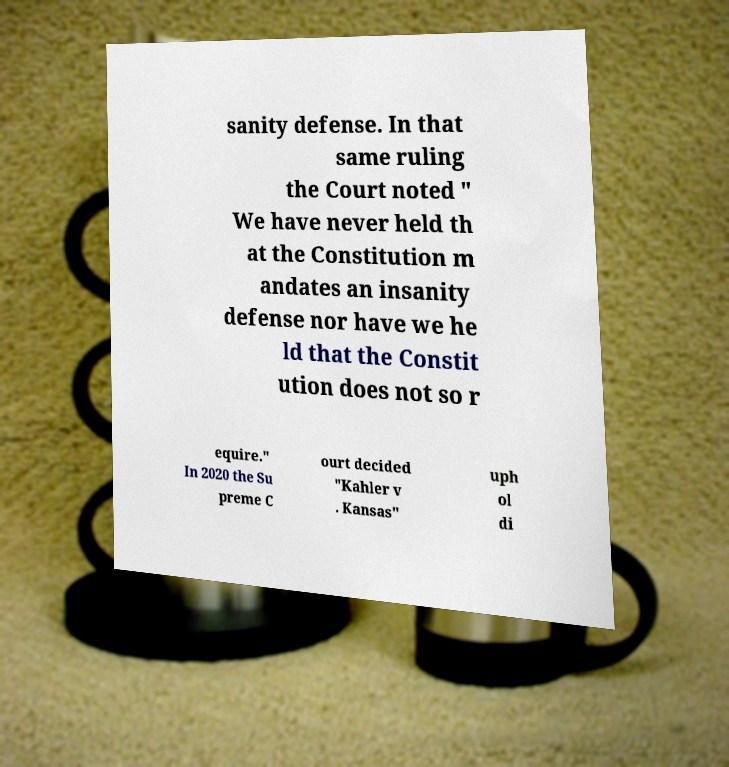For documentation purposes, I need the text within this image transcribed. Could you provide that? sanity defense. In that same ruling the Court noted " We have never held th at the Constitution m andates an insanity defense nor have we he ld that the Constit ution does not so r equire." In 2020 the Su preme C ourt decided "Kahler v . Kansas" uph ol di 